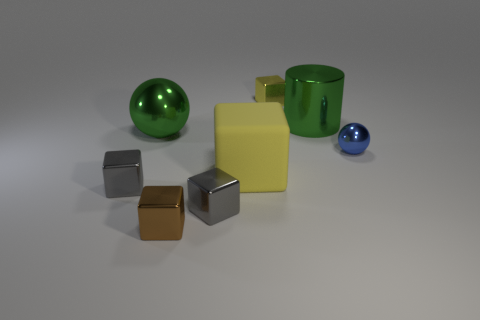Subtract all metallic blocks. How many blocks are left? 1 Subtract all yellow blocks. How many blocks are left? 3 Subtract 1 spheres. How many spheres are left? 1 Subtract all balls. How many objects are left? 6 Subtract all yellow blocks. Subtract all blue spheres. How many blocks are left? 3 Subtract all blue spheres. Subtract all green shiny cylinders. How many objects are left? 6 Add 8 large green shiny spheres. How many large green shiny spheres are left? 9 Add 5 small blue metallic objects. How many small blue metallic objects exist? 6 Add 1 tiny gray things. How many objects exist? 9 Subtract 0 cyan cylinders. How many objects are left? 8 